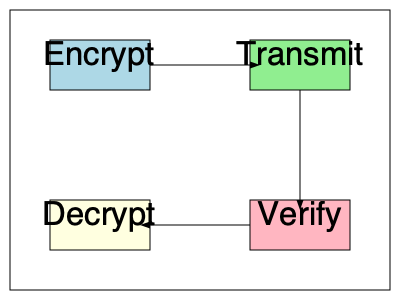In the flowchart depicting a simple data transmission process, what is the correct sequence of steps for securely transmitting sensitive medical data? To determine the correct sequence of steps for securely transmitting sensitive medical data, we need to analyze the flowchart:

1. The process starts with the "Encrypt" step, represented by the light blue box in the top left. This is crucial for securing sensitive medical data before transmission.

2. An arrow leads from "Encrypt" to "Transmit" (light green box), indicating that the encrypted data is then transmitted.

3. After transmission, the flow moves downward to the "Verify" step (light pink box). This step likely involves verifying the integrity and authenticity of the received data.

4. Finally, an arrow leads from "Verify" to "Decrypt" (light yellow box), suggesting that once the data is verified, it can be decrypted for use.

This sequence ensures that the data is protected during transmission and its integrity is verified before decryption, which is essential for handling sensitive medical information securely.
Answer: Encrypt, Transmit, Verify, Decrypt 